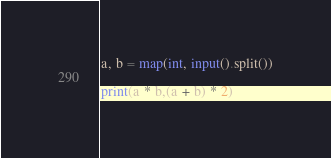<code> <loc_0><loc_0><loc_500><loc_500><_Python_>a, b = map(int, input().split())

print(a * b,(a + b) * 2)
</code> 